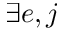Convert formula to latex. <formula><loc_0><loc_0><loc_500><loc_500>\exists e , j</formula> 